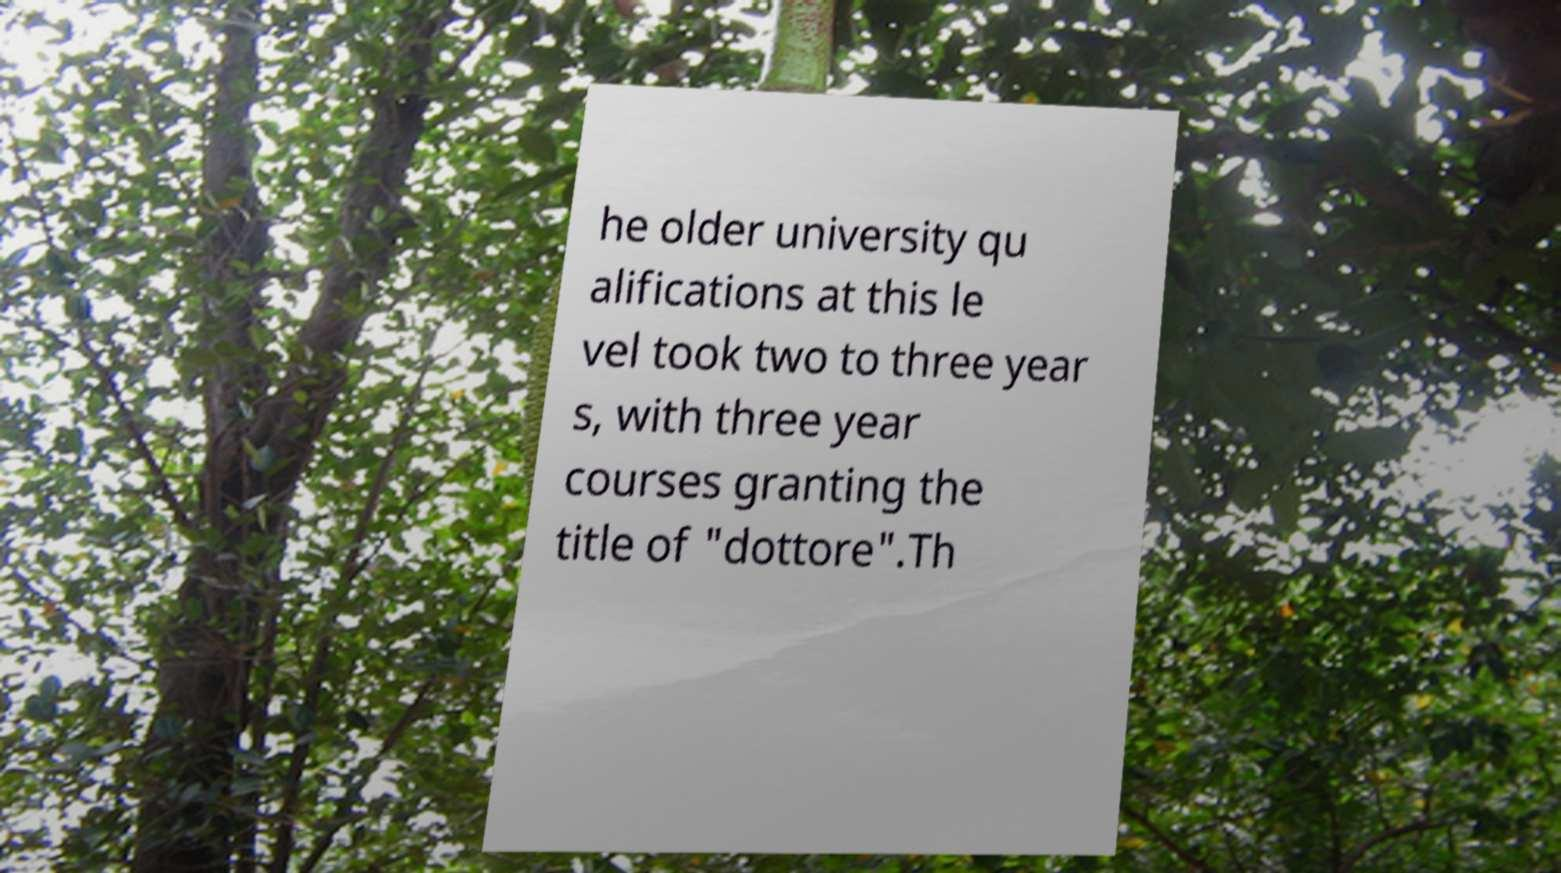Please identify and transcribe the text found in this image. he older university qu alifications at this le vel took two to three year s, with three year courses granting the title of "dottore".Th 